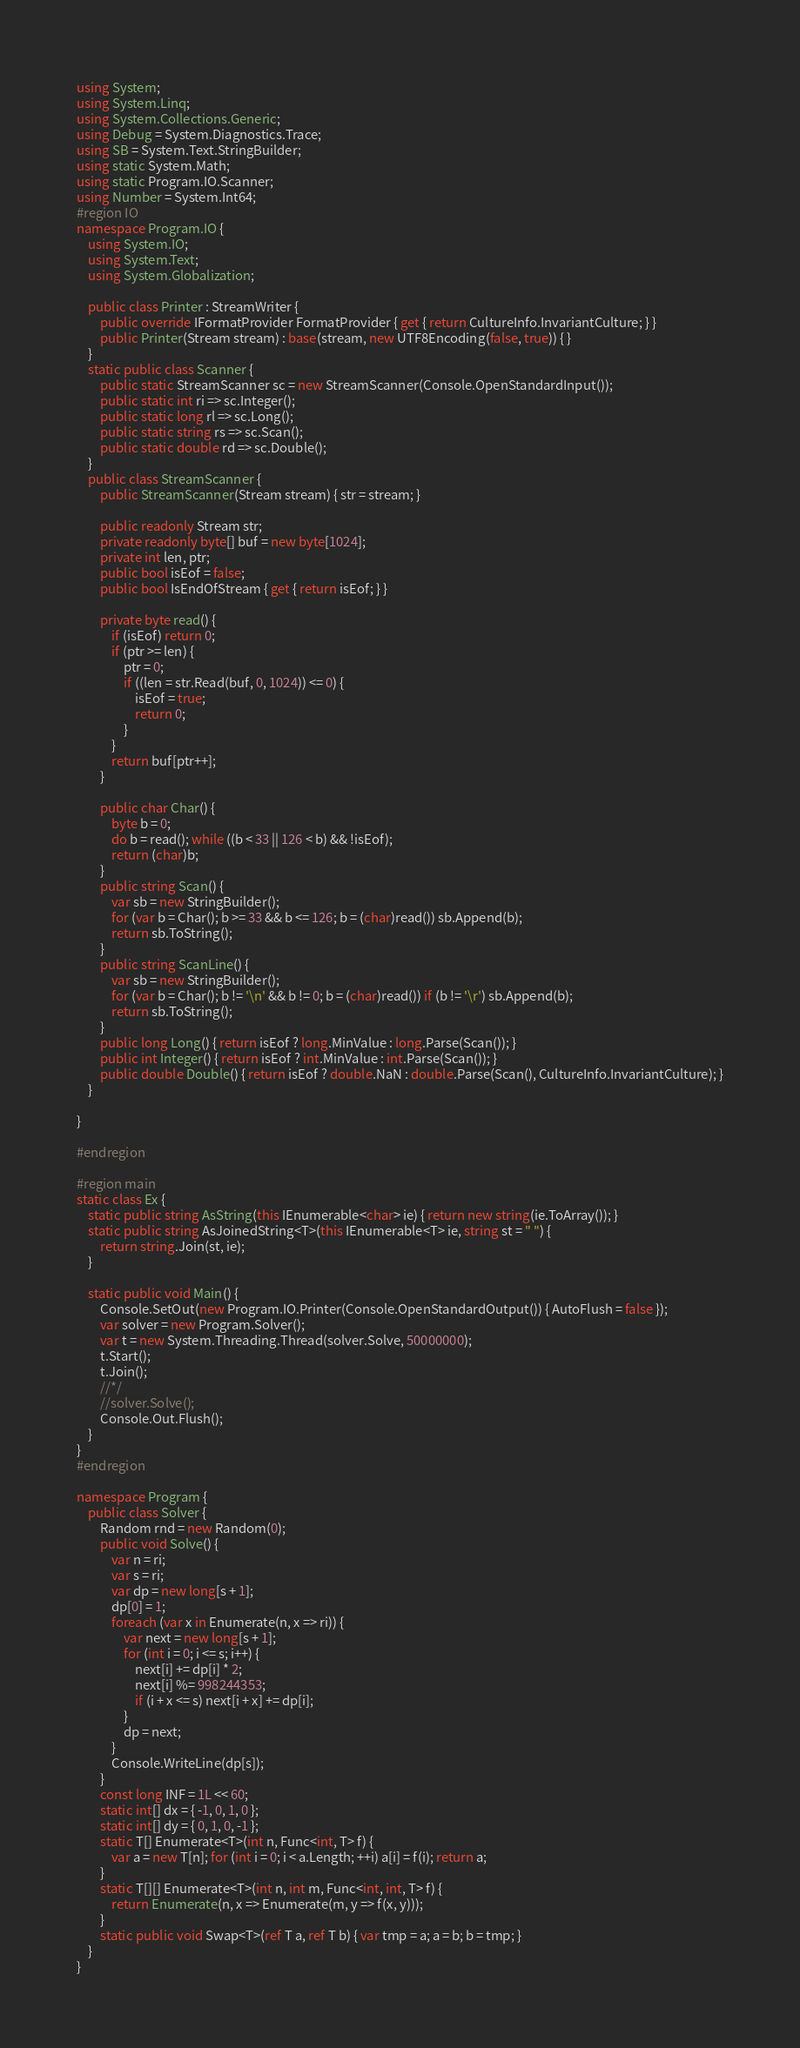Convert code to text. <code><loc_0><loc_0><loc_500><loc_500><_C#_>using System;
using System.Linq;
using System.Collections.Generic;
using Debug = System.Diagnostics.Trace;
using SB = System.Text.StringBuilder;
using static System.Math;
using static Program.IO.Scanner;
using Number = System.Int64;
#region IO
namespace Program.IO {
	using System.IO;
	using System.Text;
	using System.Globalization;

	public class Printer : StreamWriter {
		public override IFormatProvider FormatProvider { get { return CultureInfo.InvariantCulture; } }
		public Printer(Stream stream) : base(stream, new UTF8Encoding(false, true)) { }
	}
	static public class Scanner {
		public static StreamScanner sc = new StreamScanner(Console.OpenStandardInput());
		public static int ri => sc.Integer();
		public static long rl => sc.Long();
		public static string rs => sc.Scan();
		public static double rd => sc.Double();
	}
	public class StreamScanner {
		public StreamScanner(Stream stream) { str = stream; }

		public readonly Stream str;
		private readonly byte[] buf = new byte[1024];
		private int len, ptr;
		public bool isEof = false;
		public bool IsEndOfStream { get { return isEof; } }

		private byte read() {
			if (isEof) return 0;
			if (ptr >= len) {
				ptr = 0;
				if ((len = str.Read(buf, 0, 1024)) <= 0) {
					isEof = true;
					return 0;
				}
			}
			return buf[ptr++];
		}

		public char Char() {
			byte b = 0;
			do b = read(); while ((b < 33 || 126 < b) && !isEof);
			return (char)b;
		}
		public string Scan() {
			var sb = new StringBuilder();
			for (var b = Char(); b >= 33 && b <= 126; b = (char)read()) sb.Append(b);
			return sb.ToString();
		}
		public string ScanLine() {
			var sb = new StringBuilder();
			for (var b = Char(); b != '\n' && b != 0; b = (char)read()) if (b != '\r') sb.Append(b);
			return sb.ToString();
		}
		public long Long() { return isEof ? long.MinValue : long.Parse(Scan()); }
		public int Integer() { return isEof ? int.MinValue : int.Parse(Scan()); }
		public double Double() { return isEof ? double.NaN : double.Parse(Scan(), CultureInfo.InvariantCulture); }
	}

}

#endregion

#region main
static class Ex {
	static public string AsString(this IEnumerable<char> ie) { return new string(ie.ToArray()); }
	static public string AsJoinedString<T>(this IEnumerable<T> ie, string st = " ") {
		return string.Join(st, ie);
	}

	static public void Main() {
		Console.SetOut(new Program.IO.Printer(Console.OpenStandardOutput()) { AutoFlush = false });
		var solver = new Program.Solver();
		var t = new System.Threading.Thread(solver.Solve, 50000000);
		t.Start();
		t.Join();
		//*/
		//solver.Solve();
		Console.Out.Flush();
	}
}
#endregion

namespace Program {
	public class Solver {
		Random rnd = new Random(0);
		public void Solve() {
			var n = ri;
			var s = ri;
			var dp = new long[s + 1];
			dp[0] = 1;
			foreach (var x in Enumerate(n, x => ri)) {
				var next = new long[s + 1];
				for (int i = 0; i <= s; i++) {
					next[i] += dp[i] * 2;
					next[i] %= 998244353;
					if (i + x <= s) next[i + x] += dp[i];
				}
				dp = next;
			}
			Console.WriteLine(dp[s]);
		}
		const long INF = 1L << 60;
		static int[] dx = { -1, 0, 1, 0 };
		static int[] dy = { 0, 1, 0, -1 };
		static T[] Enumerate<T>(int n, Func<int, T> f) {
			var a = new T[n]; for (int i = 0; i < a.Length; ++i) a[i] = f(i); return a;
		}
		static T[][] Enumerate<T>(int n, int m, Func<int, int, T> f) {
			return Enumerate(n, x => Enumerate(m, y => f(x, y)));
		}
		static public void Swap<T>(ref T a, ref T b) { var tmp = a; a = b; b = tmp; }
	}
}
</code> 